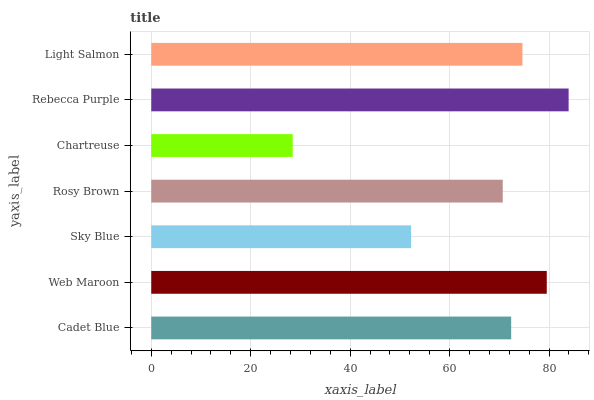Is Chartreuse the minimum?
Answer yes or no. Yes. Is Rebecca Purple the maximum?
Answer yes or no. Yes. Is Web Maroon the minimum?
Answer yes or no. No. Is Web Maroon the maximum?
Answer yes or no. No. Is Web Maroon greater than Cadet Blue?
Answer yes or no. Yes. Is Cadet Blue less than Web Maroon?
Answer yes or no. Yes. Is Cadet Blue greater than Web Maroon?
Answer yes or no. No. Is Web Maroon less than Cadet Blue?
Answer yes or no. No. Is Cadet Blue the high median?
Answer yes or no. Yes. Is Cadet Blue the low median?
Answer yes or no. Yes. Is Light Salmon the high median?
Answer yes or no. No. Is Rebecca Purple the low median?
Answer yes or no. No. 